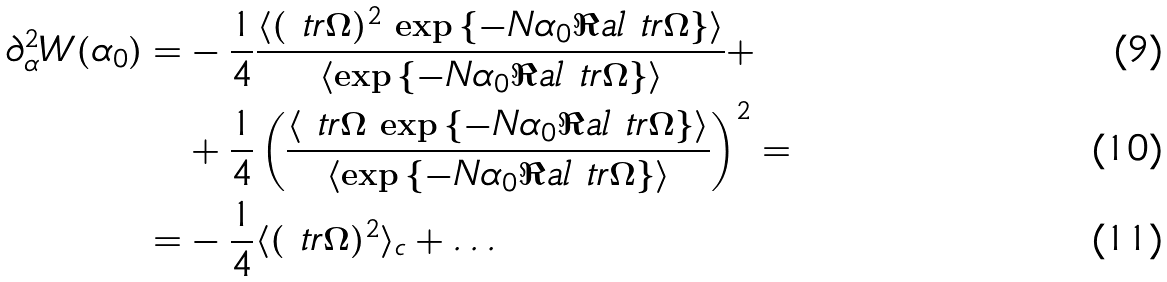<formula> <loc_0><loc_0><loc_500><loc_500>\partial ^ { 2 } _ { \alpha } W ( \alpha _ { 0 } ) = & - \frac { 1 } { 4 } \frac { \langle ( \ t r \Omega ) ^ { 2 } \, \exp \left \{ - N \alpha _ { 0 } \Re a l \ t r \Omega \right \} \rangle } { \langle \exp \left \{ - N \alpha _ { 0 } \Re a l \ t r \Omega \right \} \rangle } + \\ & + \frac { 1 } { 4 } \left ( \frac { \langle \ t r \Omega \, \exp \left \{ - N \alpha _ { 0 } \Re a l \ t r \Omega \right \} \rangle } { \langle \exp \left \{ - N \alpha _ { 0 } \Re a l \ t r \Omega \right \} \rangle } \right ) ^ { 2 } = \\ = & - \frac { 1 } { 4 } \langle ( \ t r \Omega ) ^ { 2 } \rangle _ { c } + \dots</formula> 